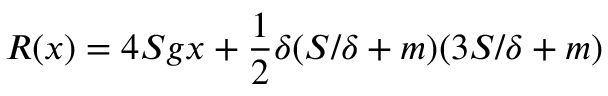<formula> <loc_0><loc_0><loc_500><loc_500>R ( x ) = 4 S g x + { \frac { 1 } { 2 } } \delta ( S / \delta + m ) ( 3 S / \delta + m )</formula> 